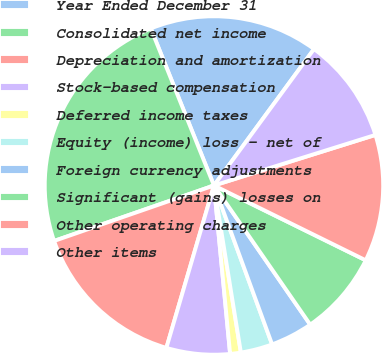Convert chart. <chart><loc_0><loc_0><loc_500><loc_500><pie_chart><fcel>Year Ended December 31<fcel>Consolidated net income<fcel>Depreciation and amortization<fcel>Stock-based compensation<fcel>Deferred income taxes<fcel>Equity (income) loss - net of<fcel>Foreign currency adjustments<fcel>Significant (gains) losses on<fcel>Other operating charges<fcel>Other items<nl><fcel>16.16%<fcel>24.23%<fcel>15.15%<fcel>6.06%<fcel>1.02%<fcel>3.04%<fcel>4.05%<fcel>8.08%<fcel>12.12%<fcel>10.1%<nl></chart> 